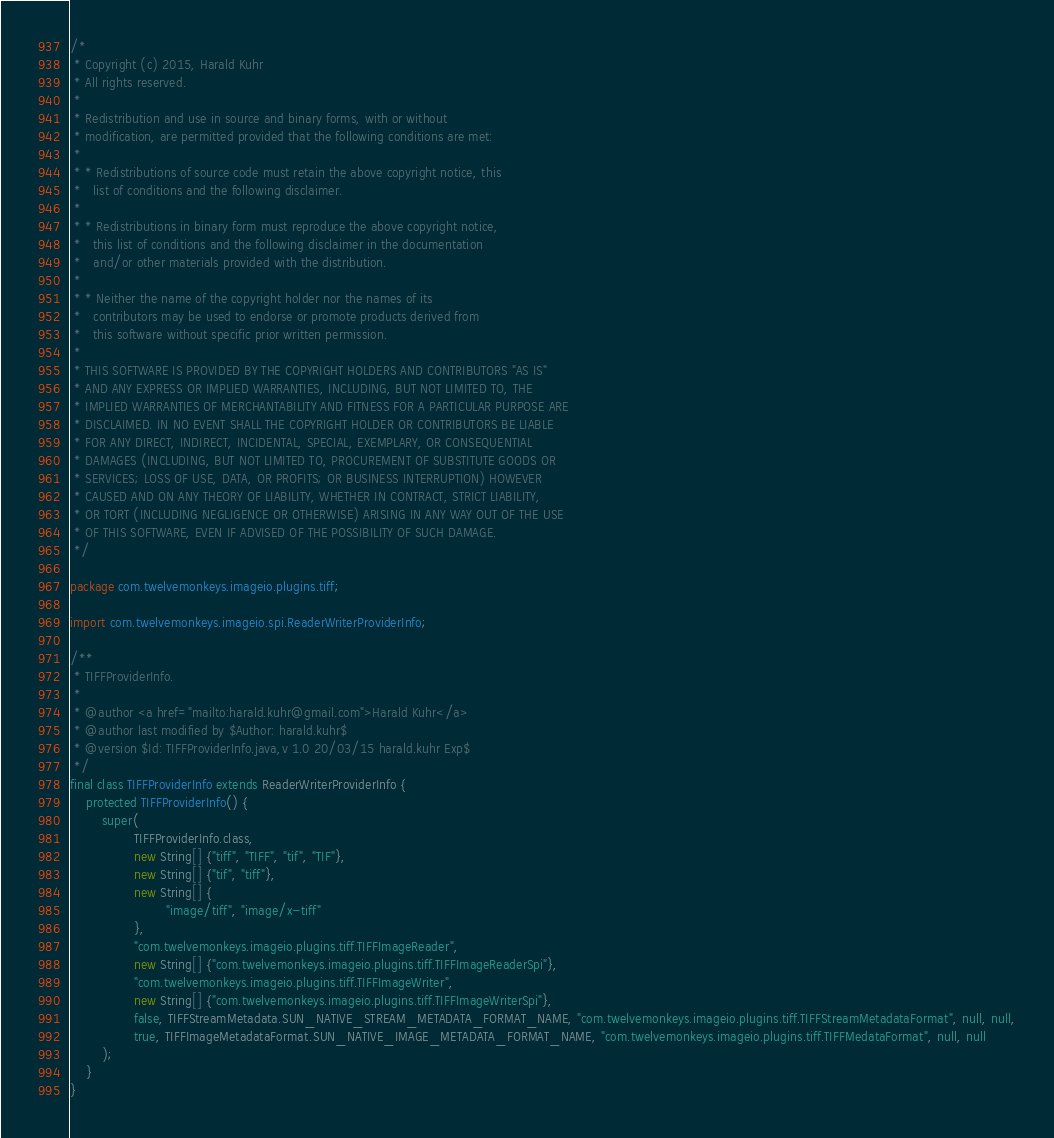<code> <loc_0><loc_0><loc_500><loc_500><_Java_>/*
 * Copyright (c) 2015, Harald Kuhr
 * All rights reserved.
 *
 * Redistribution and use in source and binary forms, with or without
 * modification, are permitted provided that the following conditions are met:
 *
 * * Redistributions of source code must retain the above copyright notice, this
 *   list of conditions and the following disclaimer.
 *
 * * Redistributions in binary form must reproduce the above copyright notice,
 *   this list of conditions and the following disclaimer in the documentation
 *   and/or other materials provided with the distribution.
 *
 * * Neither the name of the copyright holder nor the names of its
 *   contributors may be used to endorse or promote products derived from
 *   this software without specific prior written permission.
 *
 * THIS SOFTWARE IS PROVIDED BY THE COPYRIGHT HOLDERS AND CONTRIBUTORS "AS IS"
 * AND ANY EXPRESS OR IMPLIED WARRANTIES, INCLUDING, BUT NOT LIMITED TO, THE
 * IMPLIED WARRANTIES OF MERCHANTABILITY AND FITNESS FOR A PARTICULAR PURPOSE ARE
 * DISCLAIMED. IN NO EVENT SHALL THE COPYRIGHT HOLDER OR CONTRIBUTORS BE LIABLE
 * FOR ANY DIRECT, INDIRECT, INCIDENTAL, SPECIAL, EXEMPLARY, OR CONSEQUENTIAL
 * DAMAGES (INCLUDING, BUT NOT LIMITED TO, PROCUREMENT OF SUBSTITUTE GOODS OR
 * SERVICES; LOSS OF USE, DATA, OR PROFITS; OR BUSINESS INTERRUPTION) HOWEVER
 * CAUSED AND ON ANY THEORY OF LIABILITY, WHETHER IN CONTRACT, STRICT LIABILITY,
 * OR TORT (INCLUDING NEGLIGENCE OR OTHERWISE) ARISING IN ANY WAY OUT OF THE USE
 * OF THIS SOFTWARE, EVEN IF ADVISED OF THE POSSIBILITY OF SUCH DAMAGE.
 */

package com.twelvemonkeys.imageio.plugins.tiff;

import com.twelvemonkeys.imageio.spi.ReaderWriterProviderInfo;

/**
 * TIFFProviderInfo.
 *
 * @author <a href="mailto:harald.kuhr@gmail.com">Harald Kuhr</a>
 * @author last modified by $Author: harald.kuhr$
 * @version $Id: TIFFProviderInfo.java,v 1.0 20/03/15 harald.kuhr Exp$
 */
final class TIFFProviderInfo extends ReaderWriterProviderInfo {
    protected TIFFProviderInfo() {
        super(
                TIFFProviderInfo.class,
                new String[] {"tiff", "TIFF", "tif", "TIF"},
                new String[] {"tif", "tiff"},
                new String[] {
                        "image/tiff", "image/x-tiff"
                },
                "com.twelvemonkeys.imageio.plugins.tiff.TIFFImageReader",
                new String[] {"com.twelvemonkeys.imageio.plugins.tiff.TIFFImageReaderSpi"},
                "com.twelvemonkeys.imageio.plugins.tiff.TIFFImageWriter",
                new String[] {"com.twelvemonkeys.imageio.plugins.tiff.TIFFImageWriterSpi"},
                false, TIFFStreamMetadata.SUN_NATIVE_STREAM_METADATA_FORMAT_NAME, "com.twelvemonkeys.imageio.plugins.tiff.TIFFStreamMetadataFormat", null, null,
                true, TIFFImageMetadataFormat.SUN_NATIVE_IMAGE_METADATA_FORMAT_NAME, "com.twelvemonkeys.imageio.plugins.tiff.TIFFMedataFormat", null, null
        );
    }
}
</code> 